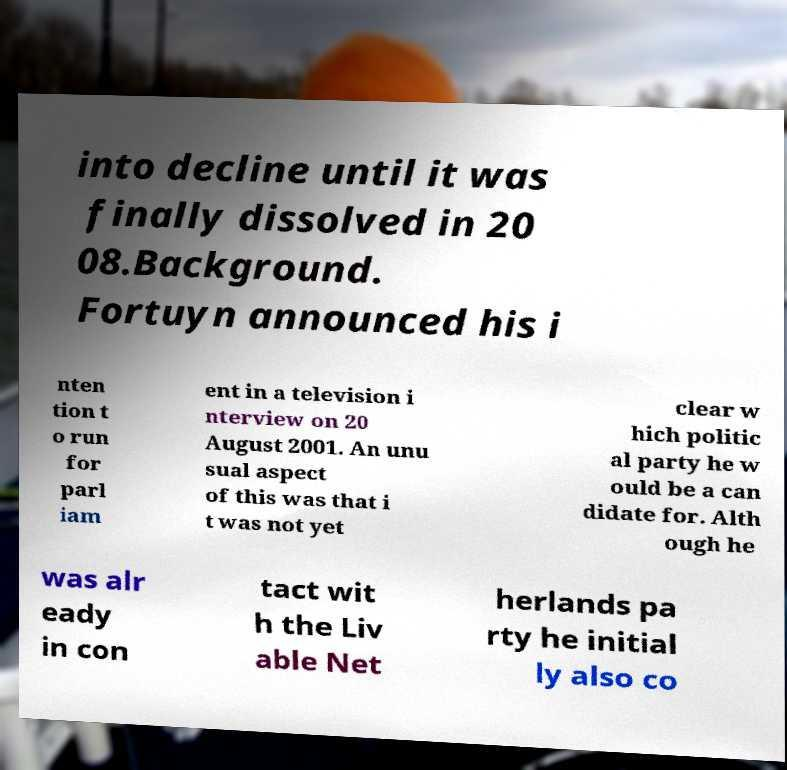What messages or text are displayed in this image? I need them in a readable, typed format. into decline until it was finally dissolved in 20 08.Background. Fortuyn announced his i nten tion t o run for parl iam ent in a television i nterview on 20 August 2001. An unu sual aspect of this was that i t was not yet clear w hich politic al party he w ould be a can didate for. Alth ough he was alr eady in con tact wit h the Liv able Net herlands pa rty he initial ly also co 